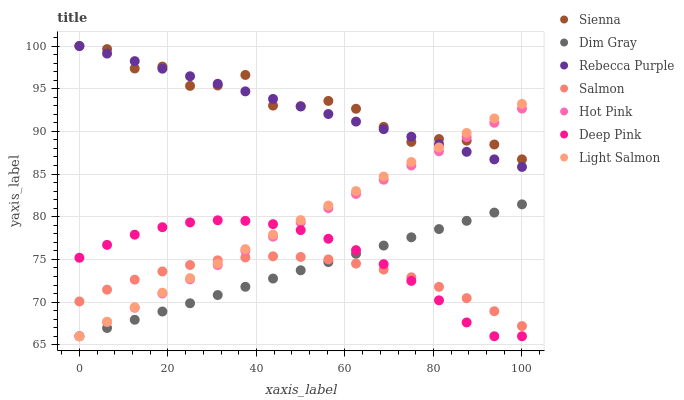Does Salmon have the minimum area under the curve?
Answer yes or no. Yes. Does Sienna have the maximum area under the curve?
Answer yes or no. Yes. Does Dim Gray have the minimum area under the curve?
Answer yes or no. No. Does Dim Gray have the maximum area under the curve?
Answer yes or no. No. Is Light Salmon the smoothest?
Answer yes or no. Yes. Is Sienna the roughest?
Answer yes or no. Yes. Is Dim Gray the smoothest?
Answer yes or no. No. Is Dim Gray the roughest?
Answer yes or no. No. Does Light Salmon have the lowest value?
Answer yes or no. Yes. Does Salmon have the lowest value?
Answer yes or no. No. Does Rebecca Purple have the highest value?
Answer yes or no. Yes. Does Dim Gray have the highest value?
Answer yes or no. No. Is Salmon less than Sienna?
Answer yes or no. Yes. Is Rebecca Purple greater than Deep Pink?
Answer yes or no. Yes. Does Hot Pink intersect Sienna?
Answer yes or no. Yes. Is Hot Pink less than Sienna?
Answer yes or no. No. Is Hot Pink greater than Sienna?
Answer yes or no. No. Does Salmon intersect Sienna?
Answer yes or no. No. 